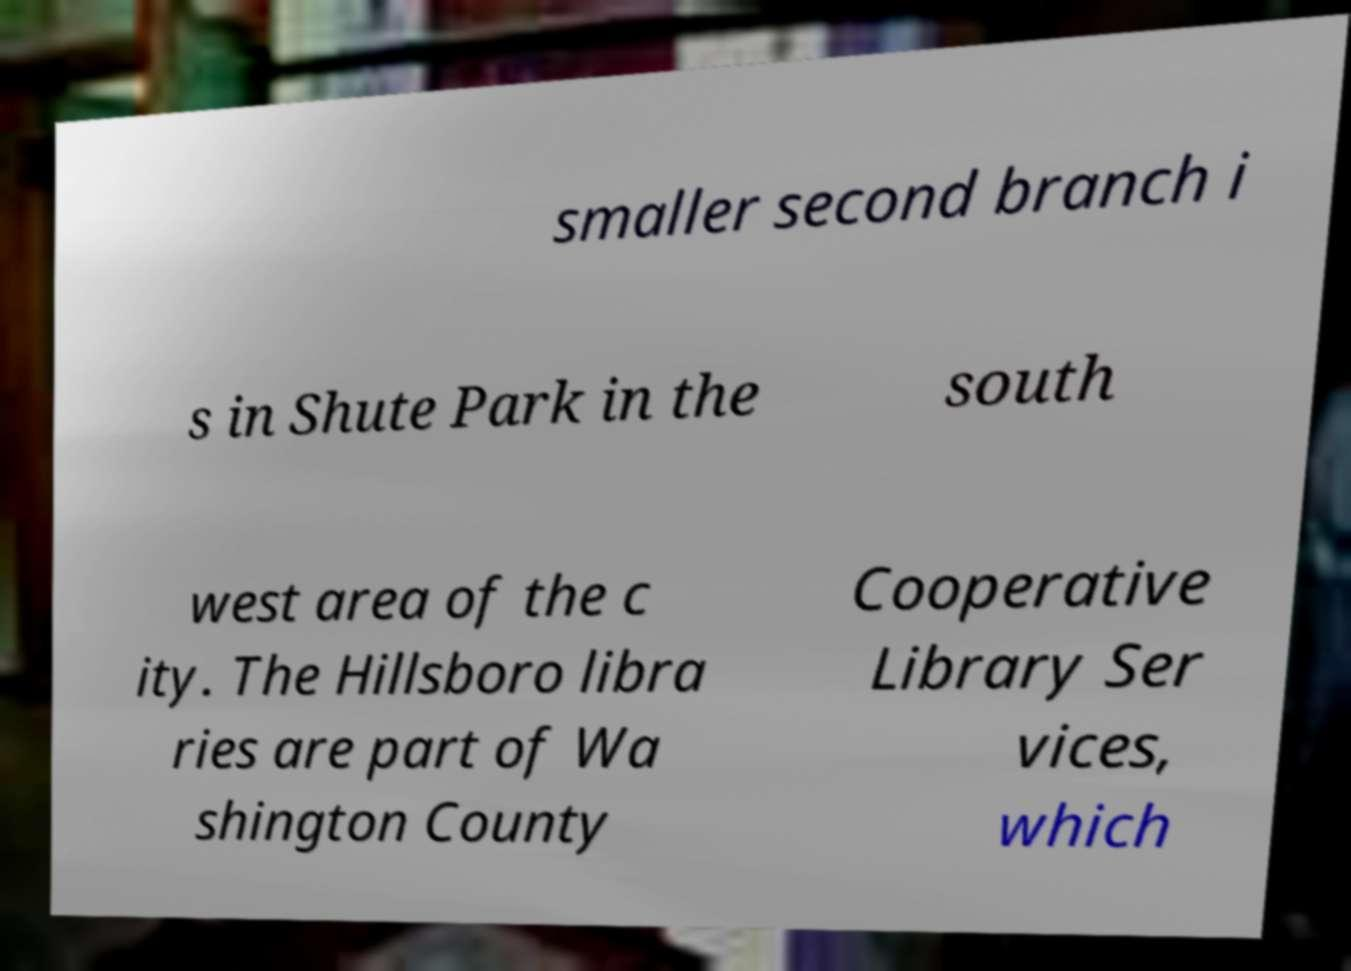I need the written content from this picture converted into text. Can you do that? smaller second branch i s in Shute Park in the south west area of the c ity. The Hillsboro libra ries are part of Wa shington County Cooperative Library Ser vices, which 